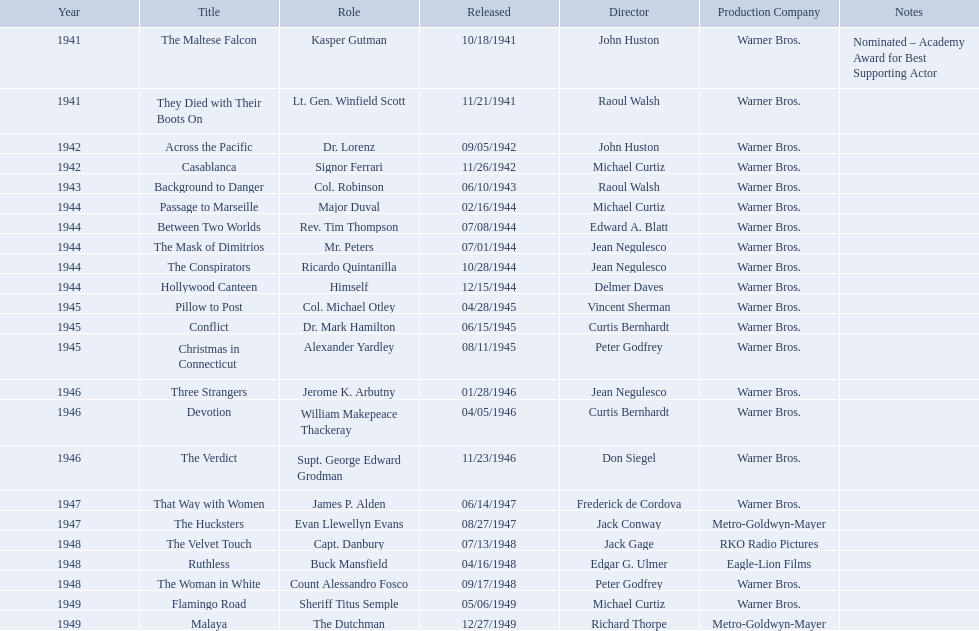What are all of the movies sydney greenstreet acted in? The Maltese Falcon, They Died with Their Boots On, Across the Pacific, Casablanca, Background to Danger, Passage to Marseille, Between Two Worlds, The Mask of Dimitrios, The Conspirators, Hollywood Canteen, Pillow to Post, Conflict, Christmas in Connecticut, Three Strangers, Devotion, The Verdict, That Way with Women, The Hucksters, The Velvet Touch, Ruthless, The Woman in White, Flamingo Road, Malaya. Can you parse all the data within this table? {'header': ['Year', 'Title', 'Role', 'Released', 'Director', 'Production Company', 'Notes'], 'rows': [['1941', 'The Maltese Falcon', 'Kasper Gutman', '10/18/1941', 'John Huston', 'Warner Bros.', 'Nominated – Academy Award for Best Supporting Actor'], ['1941', 'They Died with Their Boots On', 'Lt. Gen. Winfield Scott', '11/21/1941', 'Raoul Walsh', 'Warner Bros.', ''], ['1942', 'Across the Pacific', 'Dr. Lorenz', '09/05/1942', 'John Huston', 'Warner Bros.', ''], ['1942', 'Casablanca', 'Signor Ferrari', '11/26/1942', 'Michael Curtiz', 'Warner Bros.', ''], ['1943', 'Background to Danger', 'Col. Robinson', '06/10/1943', 'Raoul Walsh', 'Warner Bros.', ''], ['1944', 'Passage to Marseille', 'Major Duval', '02/16/1944', 'Michael Curtiz', 'Warner Bros.', ''], ['1944', 'Between Two Worlds', 'Rev. Tim Thompson', '07/08/1944', 'Edward A. Blatt', 'Warner Bros.', ''], ['1944', 'The Mask of Dimitrios', 'Mr. Peters', '07/01/1944', 'Jean Negulesco', 'Warner Bros.', ''], ['1944', 'The Conspirators', 'Ricardo Quintanilla', '10/28/1944', 'Jean Negulesco', 'Warner Bros.', ''], ['1944', 'Hollywood Canteen', 'Himself', '12/15/1944', 'Delmer Daves', 'Warner Bros.', ''], ['1945', 'Pillow to Post', 'Col. Michael Otley', '04/28/1945', 'Vincent Sherman', 'Warner Bros.', ''], ['1945', 'Conflict', 'Dr. Mark Hamilton', '06/15/1945', 'Curtis Bernhardt', 'Warner Bros.', ''], ['1945', 'Christmas in Connecticut', 'Alexander Yardley', '08/11/1945', 'Peter Godfrey', 'Warner Bros.', ''], ['1946', 'Three Strangers', 'Jerome K. Arbutny', '01/28/1946', 'Jean Negulesco', 'Warner Bros.', ''], ['1946', 'Devotion', 'William Makepeace Thackeray', '04/05/1946', 'Curtis Bernhardt', 'Warner Bros.', ''], ['1946', 'The Verdict', 'Supt. George Edward Grodman', '11/23/1946', 'Don Siegel', 'Warner Bros.', ''], ['1947', 'That Way with Women', 'James P. Alden', '06/14/1947', 'Frederick de Cordova', 'Warner Bros.', ''], ['1947', 'The Hucksters', 'Evan Llewellyn Evans', '08/27/1947', 'Jack Conway', 'Metro-Goldwyn-Mayer', ''], ['1948', 'The Velvet Touch', 'Capt. Danbury', '07/13/1948', 'Jack Gage', 'RKO Radio Pictures', ''], ['1948', 'Ruthless', 'Buck Mansfield', '04/16/1948', 'Edgar G. Ulmer', 'Eagle-Lion Films', ''], ['1948', 'The Woman in White', 'Count Alessandro Fosco', '09/17/1948', 'Peter Godfrey', 'Warner Bros.', ''], ['1949', 'Flamingo Road', 'Sheriff Titus Semple', '05/06/1949', 'Michael Curtiz', 'Warner Bros.', ''], ['1949', 'Malaya', 'The Dutchman', '12/27/1949', 'Richard Thorpe', 'Metro-Goldwyn-Mayer', '']]} What are all of the title notes? Nominated – Academy Award for Best Supporting Actor. Which film was the award for? The Maltese Falcon. 